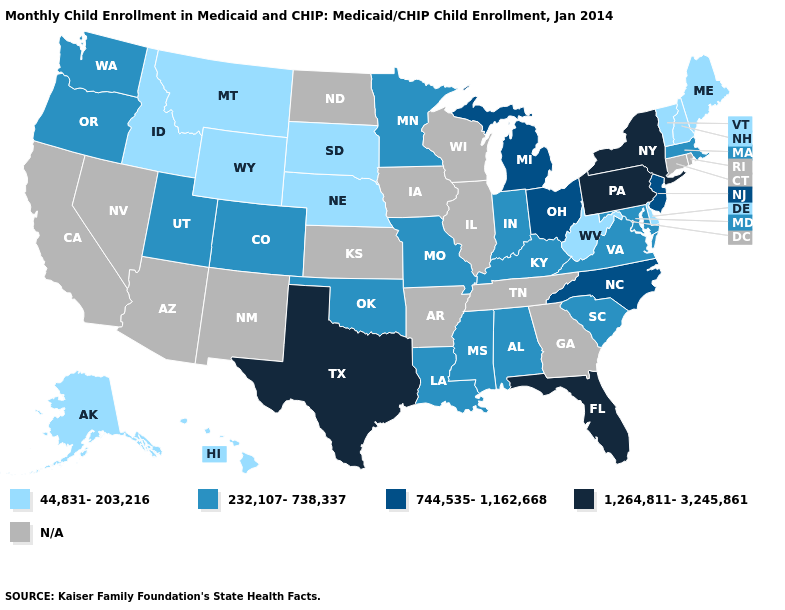Name the states that have a value in the range N/A?
Keep it brief. Arizona, Arkansas, California, Connecticut, Georgia, Illinois, Iowa, Kansas, Nevada, New Mexico, North Dakota, Rhode Island, Tennessee, Wisconsin. What is the value of Maryland?
Concise answer only. 232,107-738,337. Name the states that have a value in the range 232,107-738,337?
Be succinct. Alabama, Colorado, Indiana, Kentucky, Louisiana, Maryland, Massachusetts, Minnesota, Mississippi, Missouri, Oklahoma, Oregon, South Carolina, Utah, Virginia, Washington. What is the highest value in the USA?
Quick response, please. 1,264,811-3,245,861. Name the states that have a value in the range 744,535-1,162,668?
Short answer required. Michigan, New Jersey, North Carolina, Ohio. Name the states that have a value in the range 1,264,811-3,245,861?
Keep it brief. Florida, New York, Pennsylvania, Texas. Among the states that border Wyoming , which have the lowest value?
Write a very short answer. Idaho, Montana, Nebraska, South Dakota. Name the states that have a value in the range 44,831-203,216?
Answer briefly. Alaska, Delaware, Hawaii, Idaho, Maine, Montana, Nebraska, New Hampshire, South Dakota, Vermont, West Virginia, Wyoming. Name the states that have a value in the range N/A?
Give a very brief answer. Arizona, Arkansas, California, Connecticut, Georgia, Illinois, Iowa, Kansas, Nevada, New Mexico, North Dakota, Rhode Island, Tennessee, Wisconsin. What is the value of Arkansas?
Keep it brief. N/A. What is the highest value in the MidWest ?
Concise answer only. 744,535-1,162,668. Name the states that have a value in the range 232,107-738,337?
Concise answer only. Alabama, Colorado, Indiana, Kentucky, Louisiana, Maryland, Massachusetts, Minnesota, Mississippi, Missouri, Oklahoma, Oregon, South Carolina, Utah, Virginia, Washington. Among the states that border Virginia , does West Virginia have the lowest value?
Give a very brief answer. Yes. Does South Carolina have the highest value in the USA?
Keep it brief. No. 